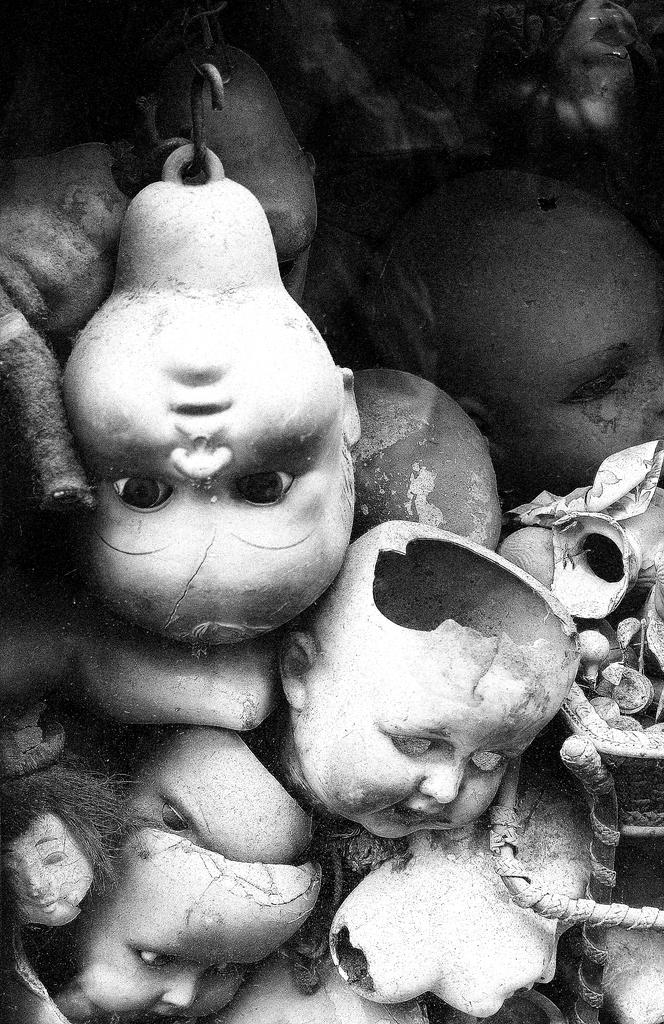What type of objects are featured in the image? There are toy faces in the image. What color scheme is used in the image? The image is in black and white. Can you tell me how many vases are depicted in the image? There are no vases present in the image; it features toy faces. What type of juice is being poured in the image? There is no juice present in the image. 